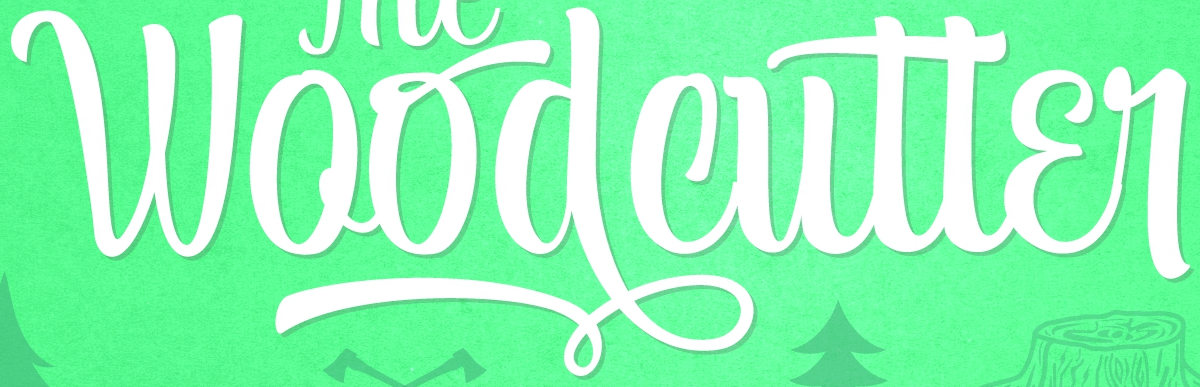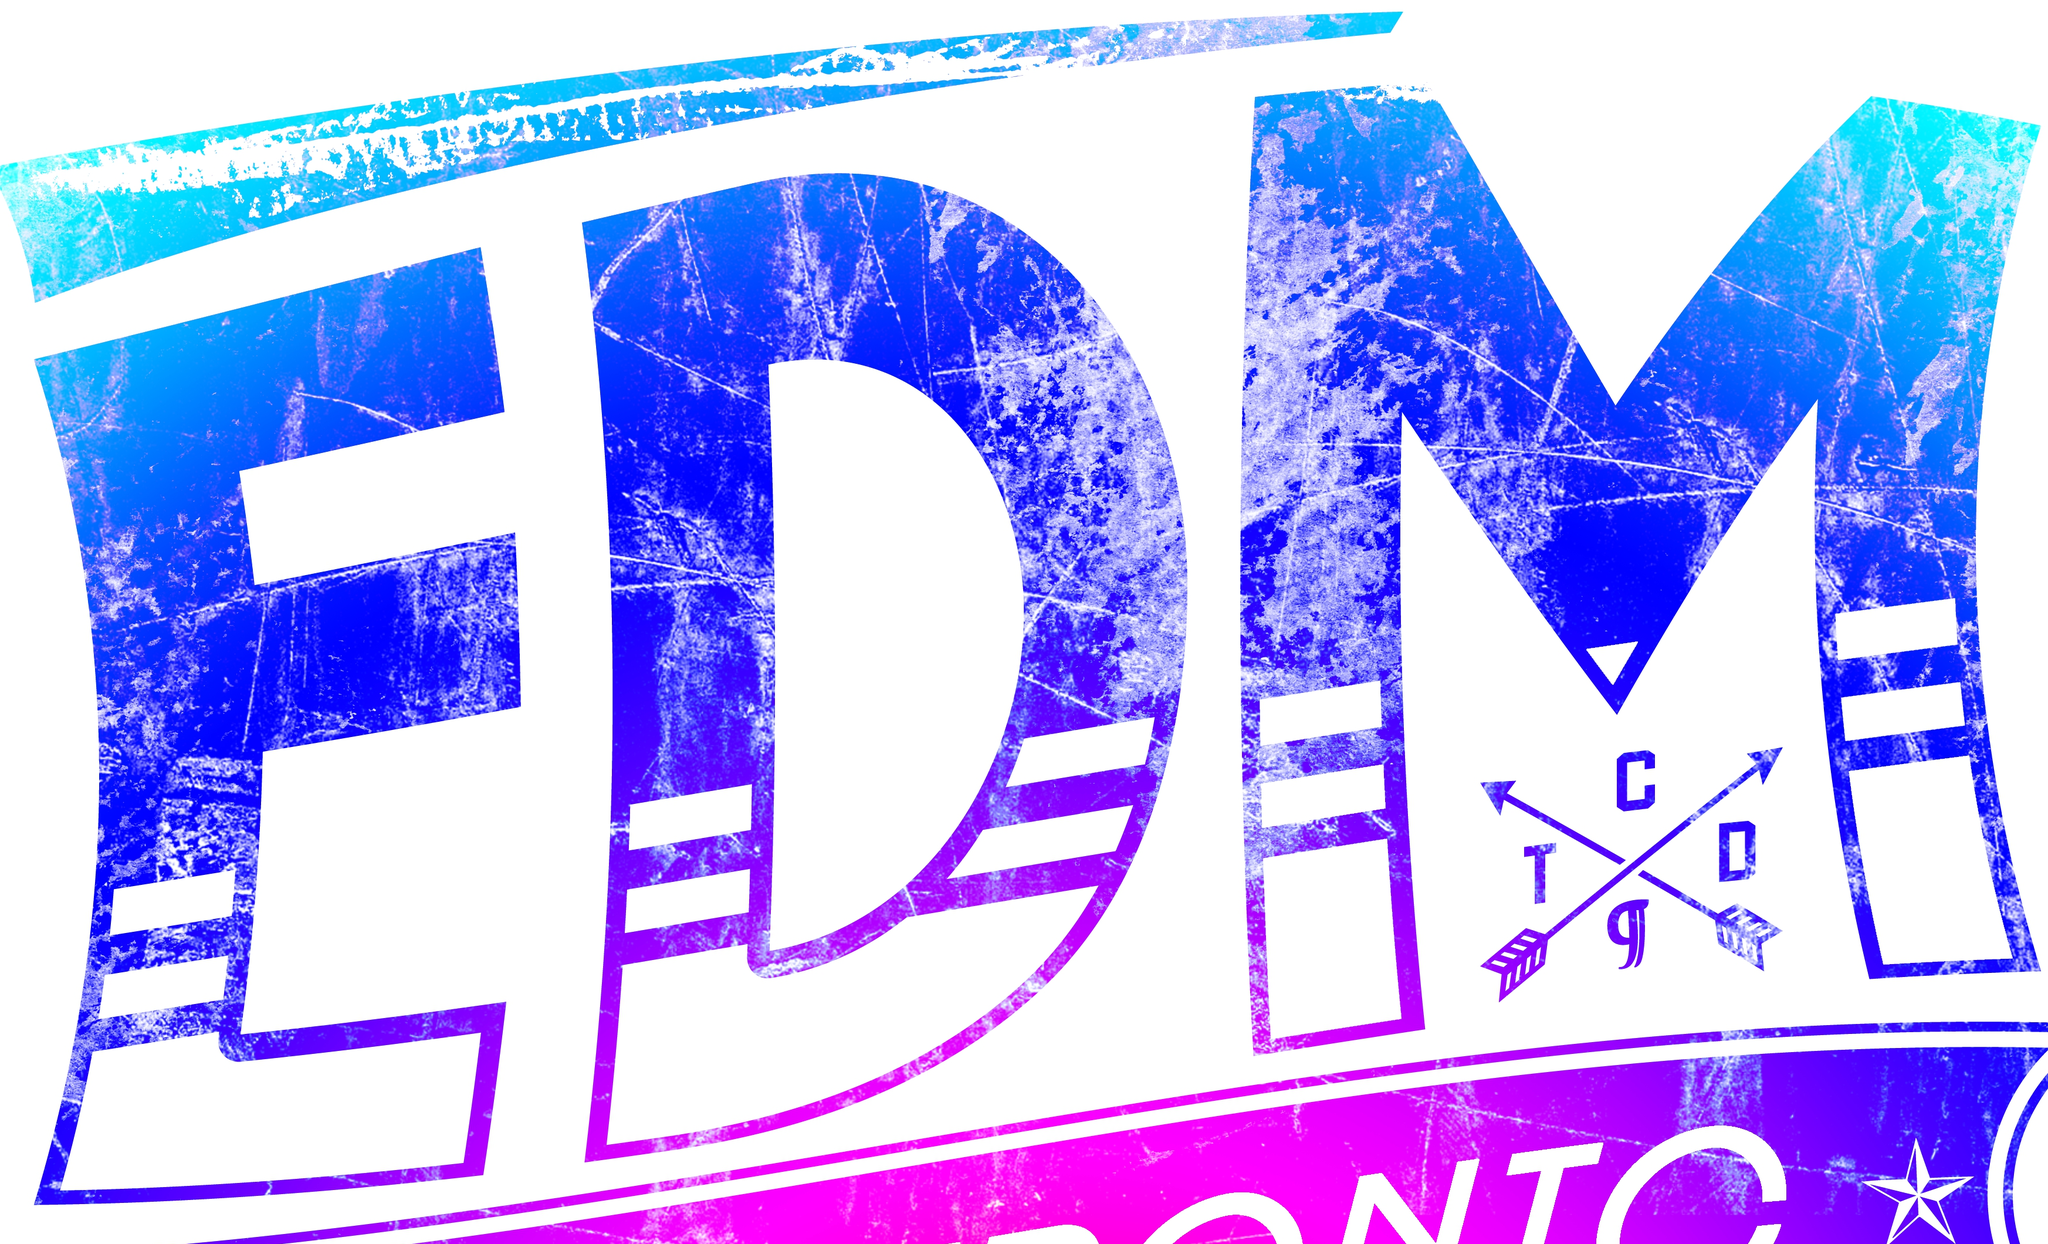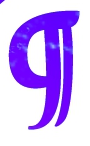Read the text from these images in sequence, separated by a semicolon. Woodcutter; EDM; g 